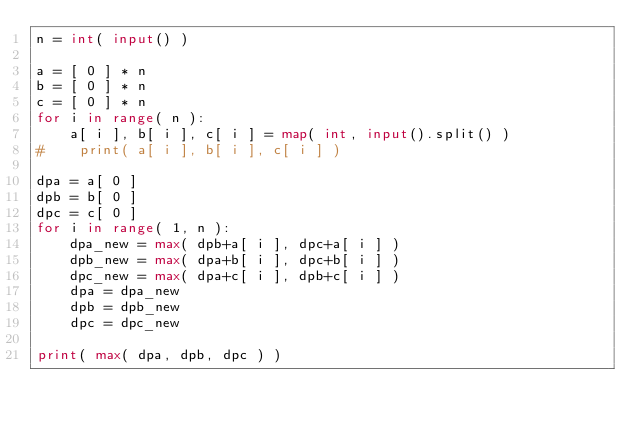<code> <loc_0><loc_0><loc_500><loc_500><_Python_>n = int( input() )

a = [ 0 ] * n
b = [ 0 ] * n
c = [ 0 ] * n
for i in range( n ):
    a[ i ], b[ i ], c[ i ] = map( int, input().split() )
#    print( a[ i ], b[ i ], c[ i ] )

dpa = a[ 0 ]
dpb = b[ 0 ]
dpc = c[ 0 ]
for i in range( 1, n ):
    dpa_new = max( dpb+a[ i ], dpc+a[ i ] )
    dpb_new = max( dpa+b[ i ], dpc+b[ i ] )
    dpc_new = max( dpa+c[ i ], dpb+c[ i ] )
    dpa = dpa_new
    dpb = dpb_new
    dpc = dpc_new

print( max( dpa, dpb, dpc ) )
</code> 